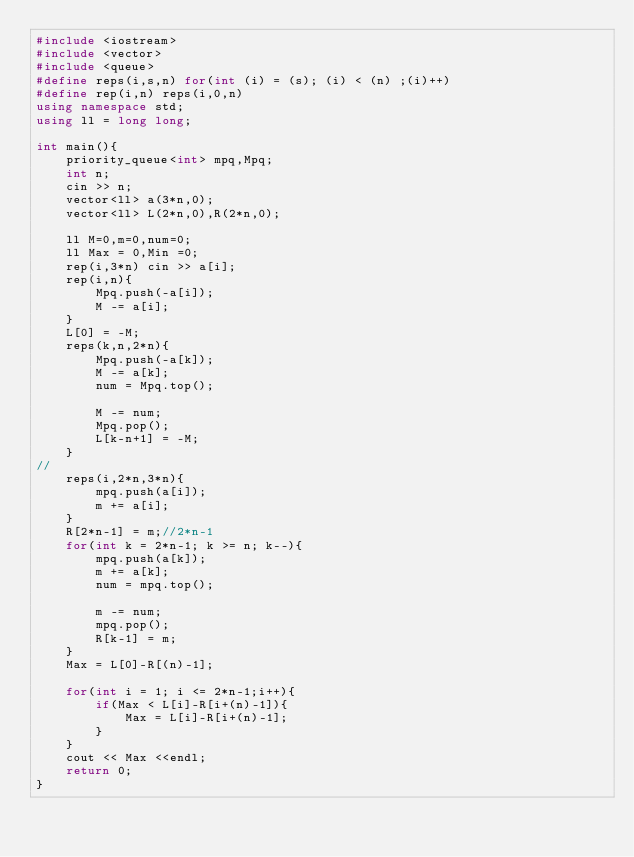Convert code to text. <code><loc_0><loc_0><loc_500><loc_500><_C++_>#include <iostream>
#include <vector>
#include <queue>
#define reps(i,s,n) for(int (i) = (s); (i) < (n) ;(i)++)
#define rep(i,n) reps(i,0,n)
using namespace std;
using ll = long long;

int main(){
    priority_queue<int> mpq,Mpq;
    int n; 
    cin >> n;
    vector<ll> a(3*n,0);
    vector<ll> L(2*n,0),R(2*n,0);

    ll M=0,m=0,num=0;
    ll Max = 0,Min =0;
    rep(i,3*n) cin >> a[i];
    rep(i,n){
        Mpq.push(-a[i]);
        M -= a[i];
    }
    L[0] = -M;
    reps(k,n,2*n){
        Mpq.push(-a[k]);
        M -= a[k];
        num = Mpq.top();

        M -= num;
        Mpq.pop();
        L[k-n+1] = -M;
    }
//
    reps(i,2*n,3*n){
        mpq.push(a[i]);
        m += a[i];
    }
    R[2*n-1] = m;//2*n-1
    for(int k = 2*n-1; k >= n; k--){
        mpq.push(a[k]);
        m += a[k];
        num = mpq.top();

        m -= num;
        mpq.pop();
        R[k-1] = m;
    }
    Max = L[0]-R[(n)-1];
    
    for(int i = 1; i <= 2*n-1;i++){
        if(Max < L[i]-R[i+(n)-1]){
            Max = L[i]-R[i+(n)-1];
        }
    }
    cout << Max <<endl;
    return 0;
}</code> 